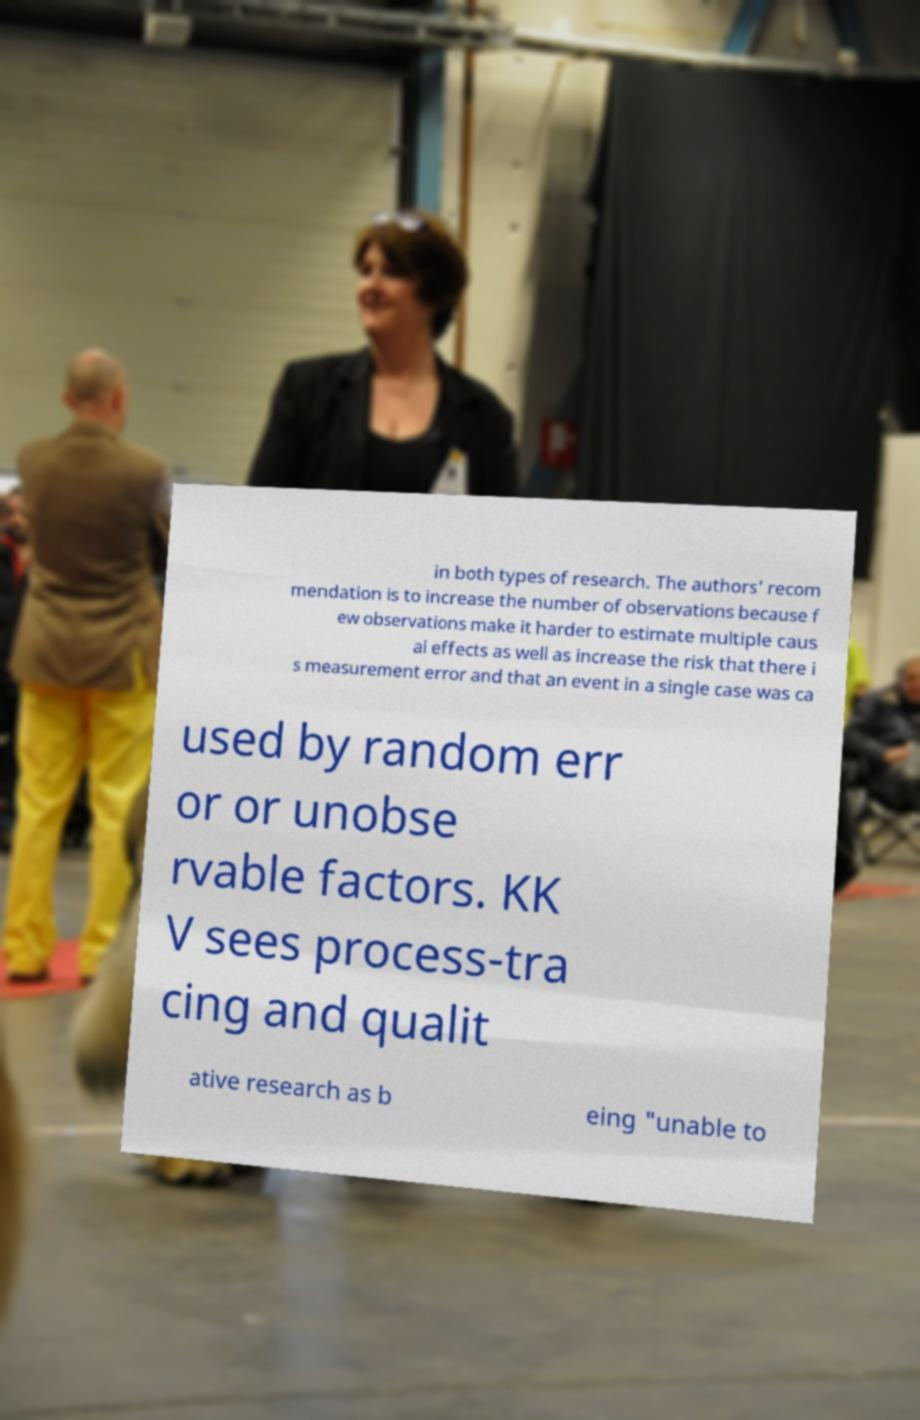I need the written content from this picture converted into text. Can you do that? in both types of research. The authors' recom mendation is to increase the number of observations because f ew observations make it harder to estimate multiple caus al effects as well as increase the risk that there i s measurement error and that an event in a single case was ca used by random err or or unobse rvable factors. KK V sees process-tra cing and qualit ative research as b eing "unable to 